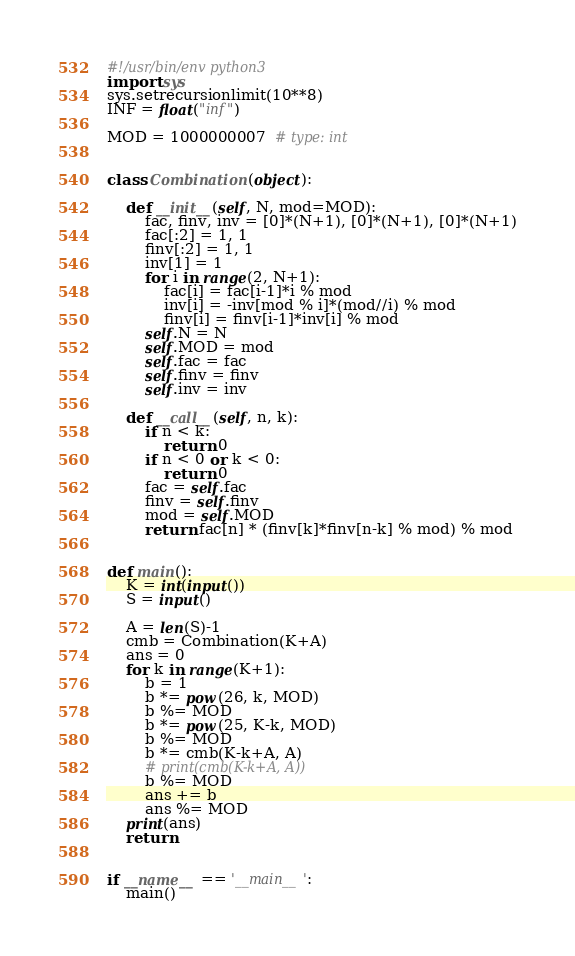<code> <loc_0><loc_0><loc_500><loc_500><_Python_>#!/usr/bin/env python3
import sys
sys.setrecursionlimit(10**8)
INF = float("inf")

MOD = 1000000007  # type: int


class Combination(object):

    def __init__(self, N, mod=MOD):
        fac, finv, inv = [0]*(N+1), [0]*(N+1), [0]*(N+1)
        fac[:2] = 1, 1
        finv[:2] = 1, 1
        inv[1] = 1
        for i in range(2, N+1):
            fac[i] = fac[i-1]*i % mod
            inv[i] = -inv[mod % i]*(mod//i) % mod
            finv[i] = finv[i-1]*inv[i] % mod
        self.N = N
        self.MOD = mod
        self.fac = fac
        self.finv = finv
        self.inv = inv

    def __call__(self, n, k):
        if n < k:
            return 0
        if n < 0 or k < 0:
            return 0
        fac = self.fac
        finv = self.finv
        mod = self.MOD
        return fac[n] * (finv[k]*finv[n-k] % mod) % mod


def main():
    K = int(input())
    S = input()

    A = len(S)-1
    cmb = Combination(K+A)
    ans = 0
    for k in range(K+1):
        b = 1
        b *= pow(26, k, MOD)
        b %= MOD
        b *= pow(25, K-k, MOD)
        b %= MOD
        b *= cmb(K-k+A, A)
        # print(cmb(K-k+A, A))
        b %= MOD
        ans += b
        ans %= MOD
    print(ans)
    return


if __name__ == '__main__':
    main()
</code> 